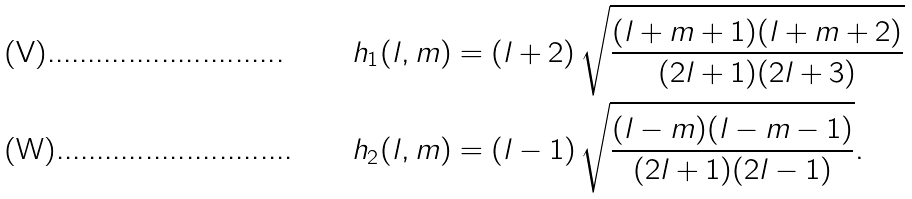<formula> <loc_0><loc_0><loc_500><loc_500>h _ { 1 } ( l , m ) & = ( l + 2 ) \, \sqrt { \frac { ( l + m + 1 ) ( l + m + 2 ) } { ( 2 l + 1 ) ( 2 l + 3 ) } } \\ h _ { 2 } ( l , m ) & = ( l - 1 ) \, \sqrt { \frac { ( l - m ) ( l - m - 1 ) } { ( 2 l + 1 ) ( 2 l - 1 ) } } .</formula> 